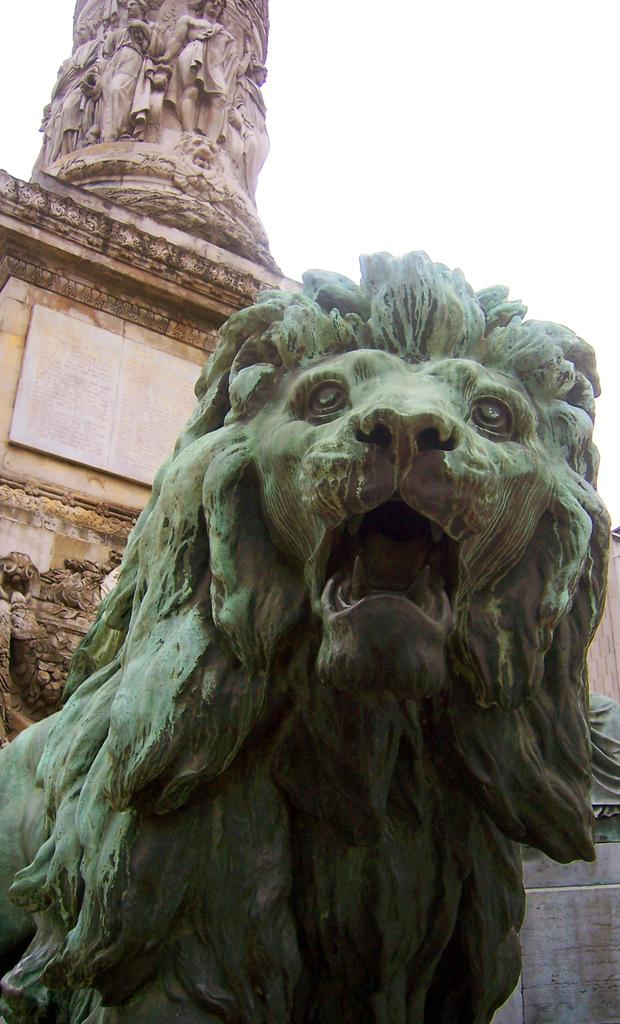What type of animal is depicted as a statue in the image? There is a statue of a lion in the image. Are there any other statues present in the image? Yes, there are other statues present on the wall in the image. What type of education does the lion statue have in the image? The lion statue is not a living being and therefore does not have an education. 